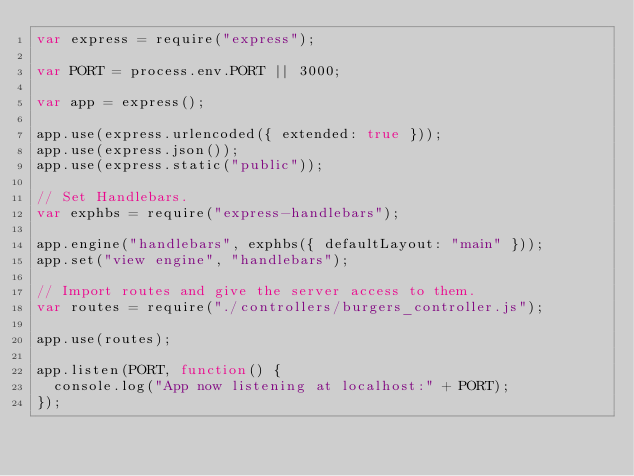<code> <loc_0><loc_0><loc_500><loc_500><_JavaScript_>var express = require("express");

var PORT = process.env.PORT || 3000;

var app = express();

app.use(express.urlencoded({ extended: true }));
app.use(express.json());
app.use(express.static("public"));

// Set Handlebars.
var exphbs = require("express-handlebars");

app.engine("handlebars", exphbs({ defaultLayout: "main" }));
app.set("view engine", "handlebars");

// Import routes and give the server access to them.
var routes = require("./controllers/burgers_controller.js");

app.use(routes);

app.listen(PORT, function() {
  console.log("App now listening at localhost:" + PORT);
});
</code> 